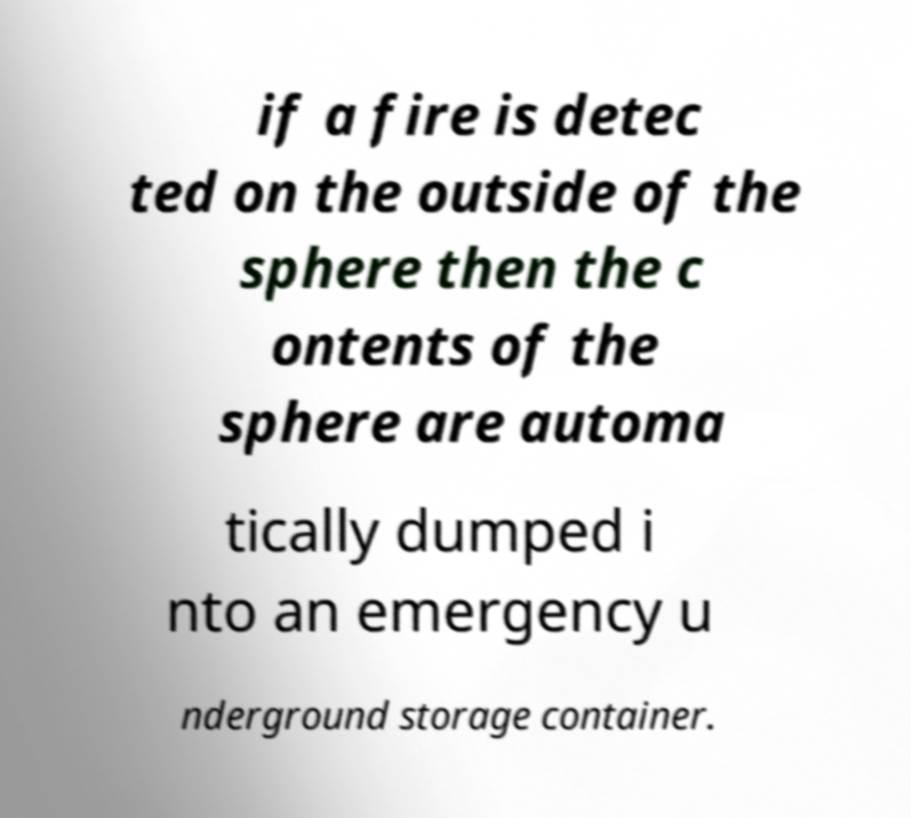Can you accurately transcribe the text from the provided image for me? if a fire is detec ted on the outside of the sphere then the c ontents of the sphere are automa tically dumped i nto an emergency u nderground storage container. 